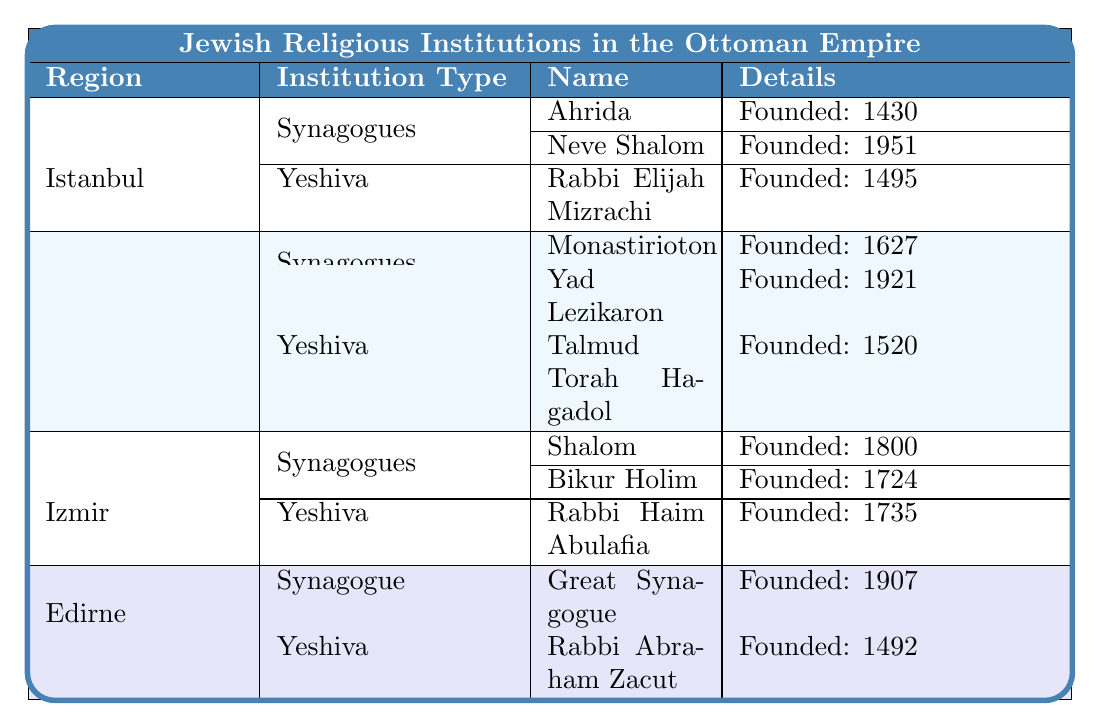What is the founding year of the Ahrida Synagogue? The Ahrida Synagogue is listed under the Istanbul region and is noted to have been founded in the year 1430.
Answer: 1430 How many synagogues are there in Edirne? The table shows that there is one synagogue in the Edirne region, referred to as the Great Synagogue.
Answer: 1 What are the notable features of the Neve Shalom Synagogue? The Neve Shalom Synagogue is noted for being built on the site of an older synagogue, according to the details provided in the table.
Answer: Built on site of older synagogue What is the founding year of the Yeshiva of Rabbi Haim Abulafia? This yeshiva is located in Izmir and is stated to have been founded in the year 1735, as detailed in the table.
Answer: 1735 Which region has the oldest synagogue according to the table? By examining the founding years of the synagogues, the Ahrida Synagogue founded in 1430 in Istanbul is the oldest among all listed synagogues.
Answer: Istanbul Which region has the most institutions listed? Both Istanbul and Thessaloniki have a total of five institutions listed (synagogues and yeshivot), making them the regions with the most institutions.
Answer: Istanbul and Thessaloniki Is the Great Synagogue of Edirne the largest synagogue in Turkey? Yes, the table refers to the Great Synagogue of Edirne as the largest synagogue in Turkey, making this statement true.
Answer: Yes Which famous scholars are associated with the Talmud Torah Hagadol? The Talmud Torah Hagadol yeshiva is associated with the famous scholars Rabbi Samuel de Medina and Rabbi Haim Abulafia as mentioned in the table.
Answer: Rabbi Samuel de Medina and Rabbi Haim Abulafia How many years apart were the founding years of the Yad Lezikaron Synagogue and the Great Synagogue of Edirne? The Yad Lezikaron Synagogue was founded in 1921 and the Great Synagogue of Edirne in 1907. The difference in years is 1921 - 1907 = 14 years.
Answer: 14 years Which city's institutions include both a synagogue established in the 16th century and a yeshiva established in the 15th century? Thessaloniki has both the Monastirioton Synagogue, founded in 1627, and the Yeshiva of Talmud Torah Hagadol, founded in 1520, fulfilling this criterion.
Answer: Thessaloniki 